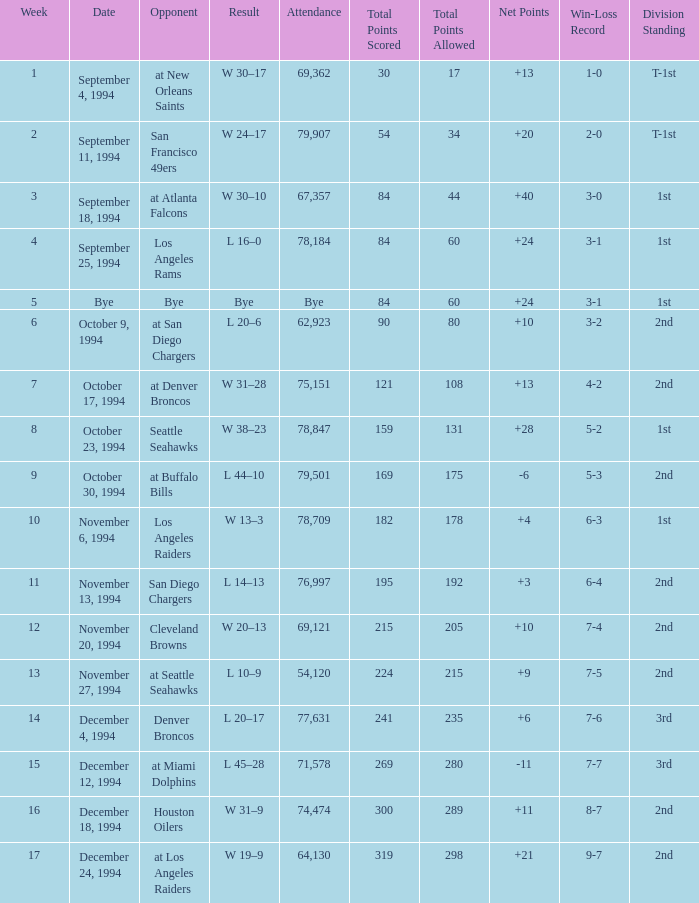Help me parse the entirety of this table. {'header': ['Week', 'Date', 'Opponent', 'Result', 'Attendance', 'Total Points Scored', 'Total Points Allowed', 'Net Points', 'Win-Loss Record', 'Division Standing'], 'rows': [['1', 'September 4, 1994', 'at New Orleans Saints', 'W 30–17', '69,362', '30', '17', '+13', '1-0', 'T-1st'], ['2', 'September 11, 1994', 'San Francisco 49ers', 'W 24–17', '79,907', '54', '34', '+20', '2-0', 'T-1st'], ['3', 'September 18, 1994', 'at Atlanta Falcons', 'W 30–10', '67,357', '84', '44', '+40', '3-0', '1st'], ['4', 'September 25, 1994', 'Los Angeles Rams', 'L 16–0', '78,184', '84', '60', '+24', '3-1', '1st'], ['5', 'Bye', 'Bye', 'Bye', 'Bye', '84', '60', '+24', '3-1', '1st'], ['6', 'October 9, 1994', 'at San Diego Chargers', 'L 20–6', '62,923', '90', '80', '+10', '3-2', '2nd'], ['7', 'October 17, 1994', 'at Denver Broncos', 'W 31–28', '75,151', '121', '108', '+13', '4-2', '2nd'], ['8', 'October 23, 1994', 'Seattle Seahawks', 'W 38–23', '78,847', '159', '131', '+28', '5-2', '1st'], ['9', 'October 30, 1994', 'at Buffalo Bills', 'L 44–10', '79,501', '169', '175', '-6', '5-3', '2nd'], ['10', 'November 6, 1994', 'Los Angeles Raiders', 'W 13–3', '78,709', '182', '178', '+4', '6-3', '1st'], ['11', 'November 13, 1994', 'San Diego Chargers', 'L 14–13', '76,997', '195', '192', '+3', '6-4', '2nd'], ['12', 'November 20, 1994', 'Cleveland Browns', 'W 20–13', '69,121', '215', '205', '+10', '7-4', '2nd'], ['13', 'November 27, 1994', 'at Seattle Seahawks', 'L 10–9', '54,120', '224', '215', '+9', '7-5', '2nd'], ['14', 'December 4, 1994', 'Denver Broncos', 'L 20–17', '77,631', '241', '235', '+6', '7-6', '3rd'], ['15', 'December 12, 1994', 'at Miami Dolphins', 'L 45–28', '71,578', '269', '280', '-11', '7-7', '3rd'], ['16', 'December 18, 1994', 'Houston Oilers', 'W 31–9', '74,474', '300', '289', '+11', '8-7', '2nd'], ['17', 'December 24, 1994', 'at Los Angeles Raiders', 'W 19–9', '64,130', '319', '298', '+21', '9-7', '2nd']]} What was the score of the Chiefs pre-Week 16 game that 69,362 people attended? W 30–17. 